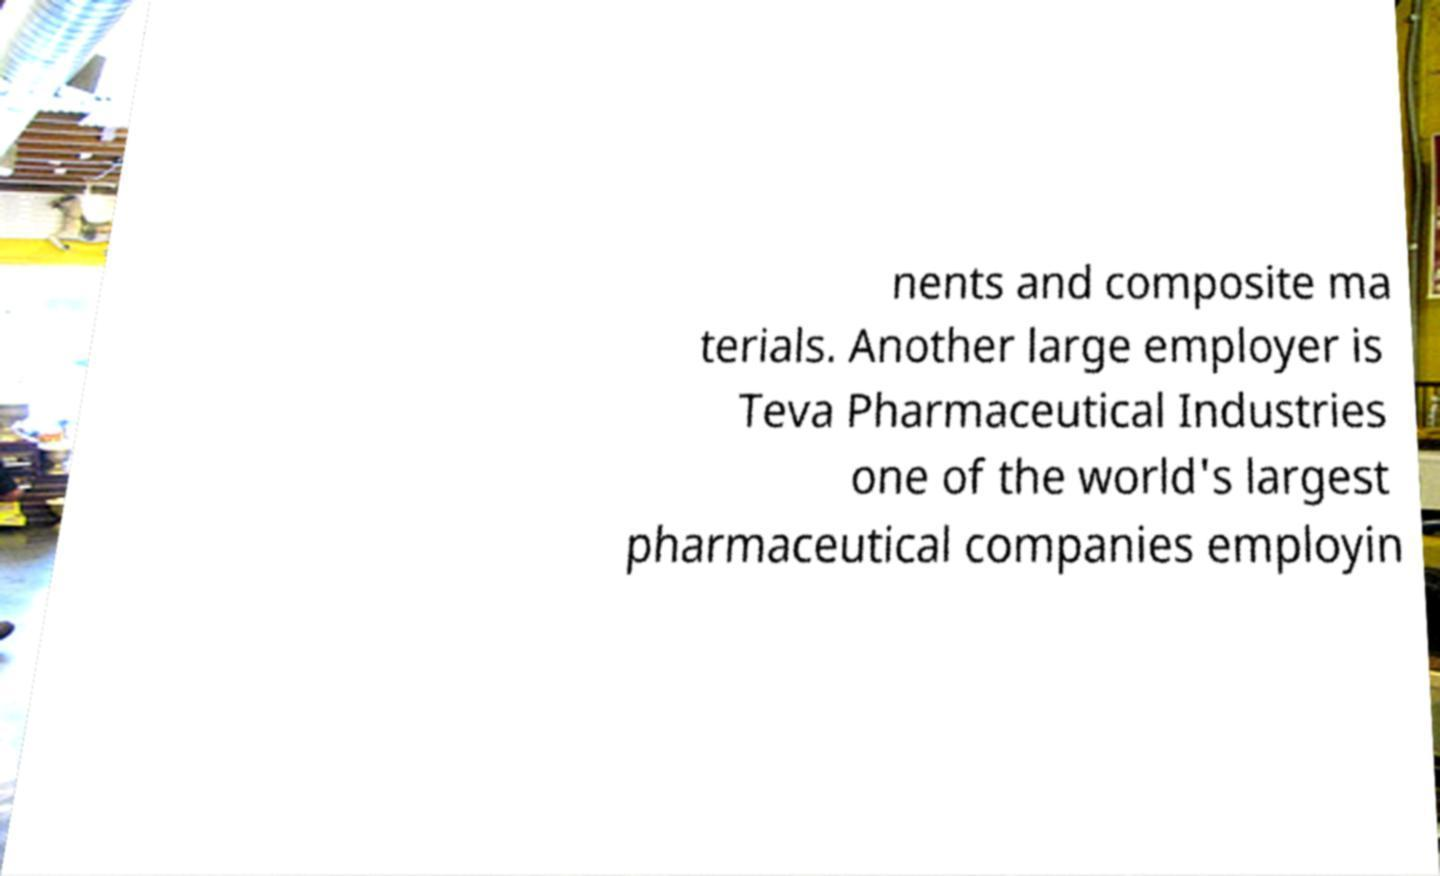Can you accurately transcribe the text from the provided image for me? nents and composite ma terials. Another large employer is Teva Pharmaceutical Industries one of the world's largest pharmaceutical companies employin 